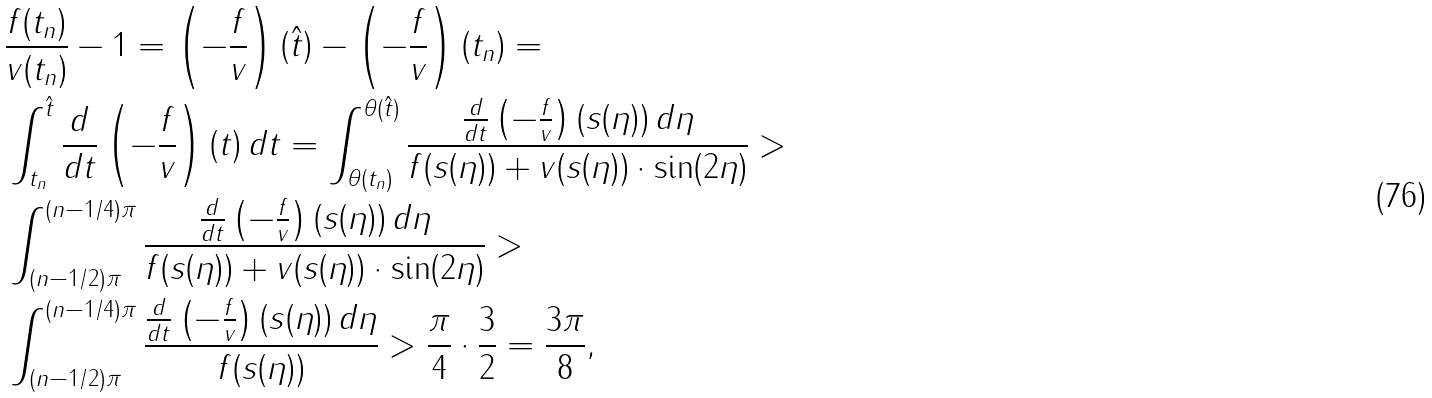Convert formula to latex. <formula><loc_0><loc_0><loc_500><loc_500>& \frac { f ( t _ { n } ) } { v ( t _ { n } ) } - 1 = \left ( - \frac { f } { v } \right ) ( \hat { t } ) - \left ( - \frac { f } { v } \right ) ( t _ { n } ) = \\ & \int _ { t _ { n } } ^ { \hat { t } } \frac { d } { d t } \left ( - \frac { f } { v } \right ) ( t ) \, d t = \int _ { \theta ( t _ { n } ) } ^ { \theta ( \hat { t } ) } \frac { \frac { d } { d t } \left ( - \frac { f } { v } \right ) ( s ( \eta ) ) \, d \eta } { f ( s ( \eta ) ) + v ( s ( \eta ) ) \cdot \sin ( 2 \eta ) } > \\ & \int _ { ( n - 1 / 2 ) \pi } ^ { ( n - 1 / 4 ) \pi } \frac { \frac { d } { d t } \left ( - \frac { f } { v } \right ) ( s ( \eta ) ) \, d \eta } { f ( s ( \eta ) ) + v ( s ( \eta ) ) \cdot \sin ( 2 \eta ) } > \\ & \int _ { ( n - 1 / 2 ) \pi } ^ { ( n - 1 / 4 ) \pi } \frac { \frac { d } { d t } \left ( - \frac { f } { v } \right ) ( s ( \eta ) ) \, d \eta } { f ( s ( \eta ) ) } > \frac { \pi } { 4 } \cdot \frac { 3 } { 2 } = \frac { 3 \pi } { 8 } ,</formula> 